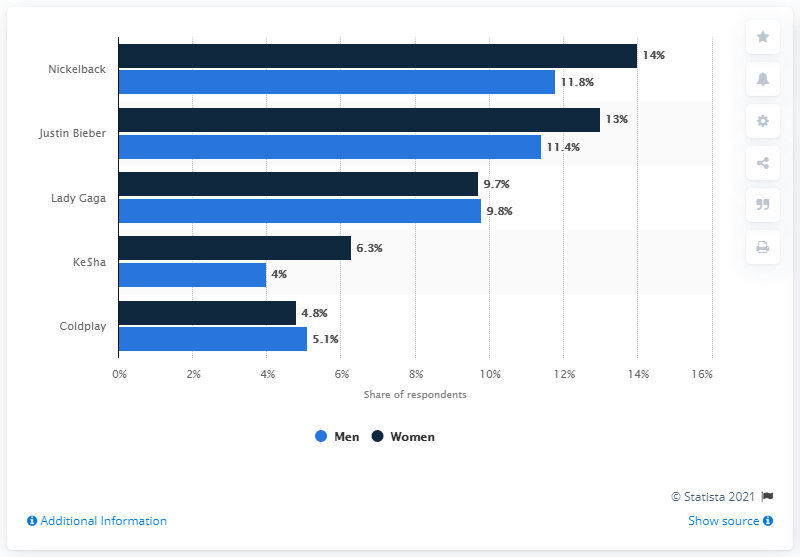Specify some key components in this picture. In 2011, the biggest musical turnoff on Tastebuds.fm was Nickelback, as stated by a user. 